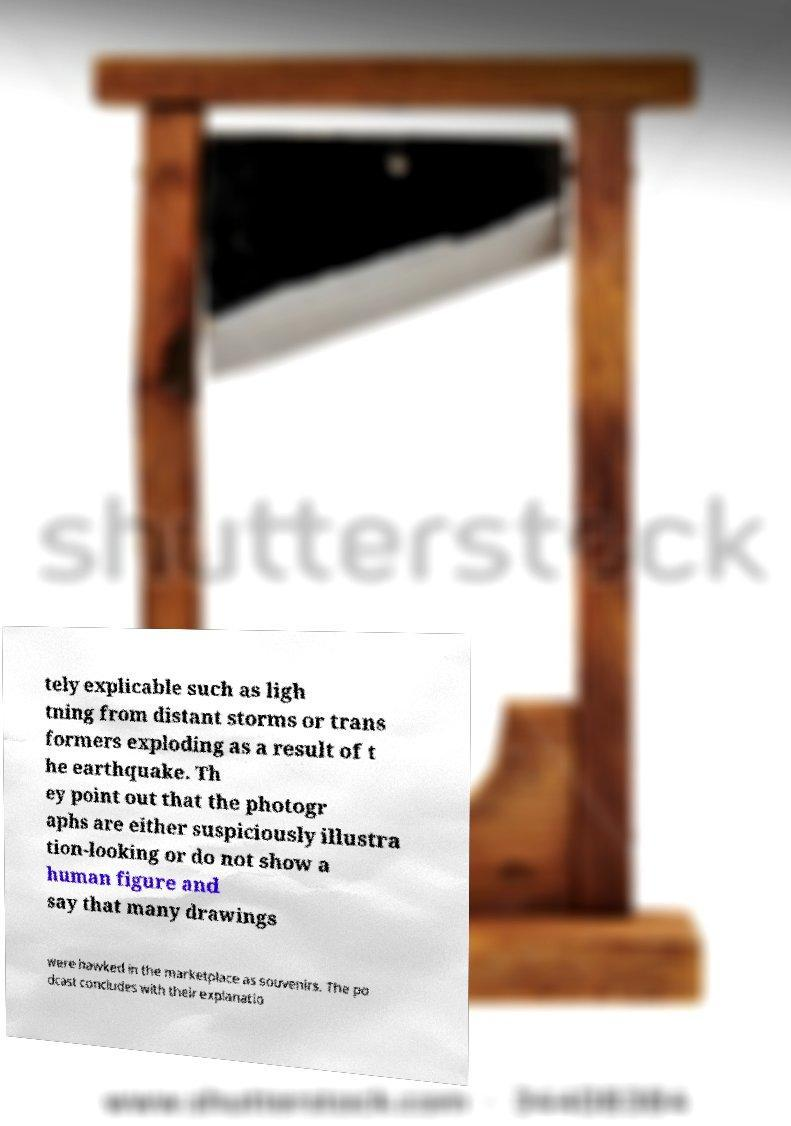I need the written content from this picture converted into text. Can you do that? tely explicable such as ligh tning from distant storms or trans formers exploding as a result of t he earthquake. Th ey point out that the photogr aphs are either suspiciously illustra tion-looking or do not show a human figure and say that many drawings were hawked in the marketplace as souvenirs. The po dcast concludes with their explanatio 